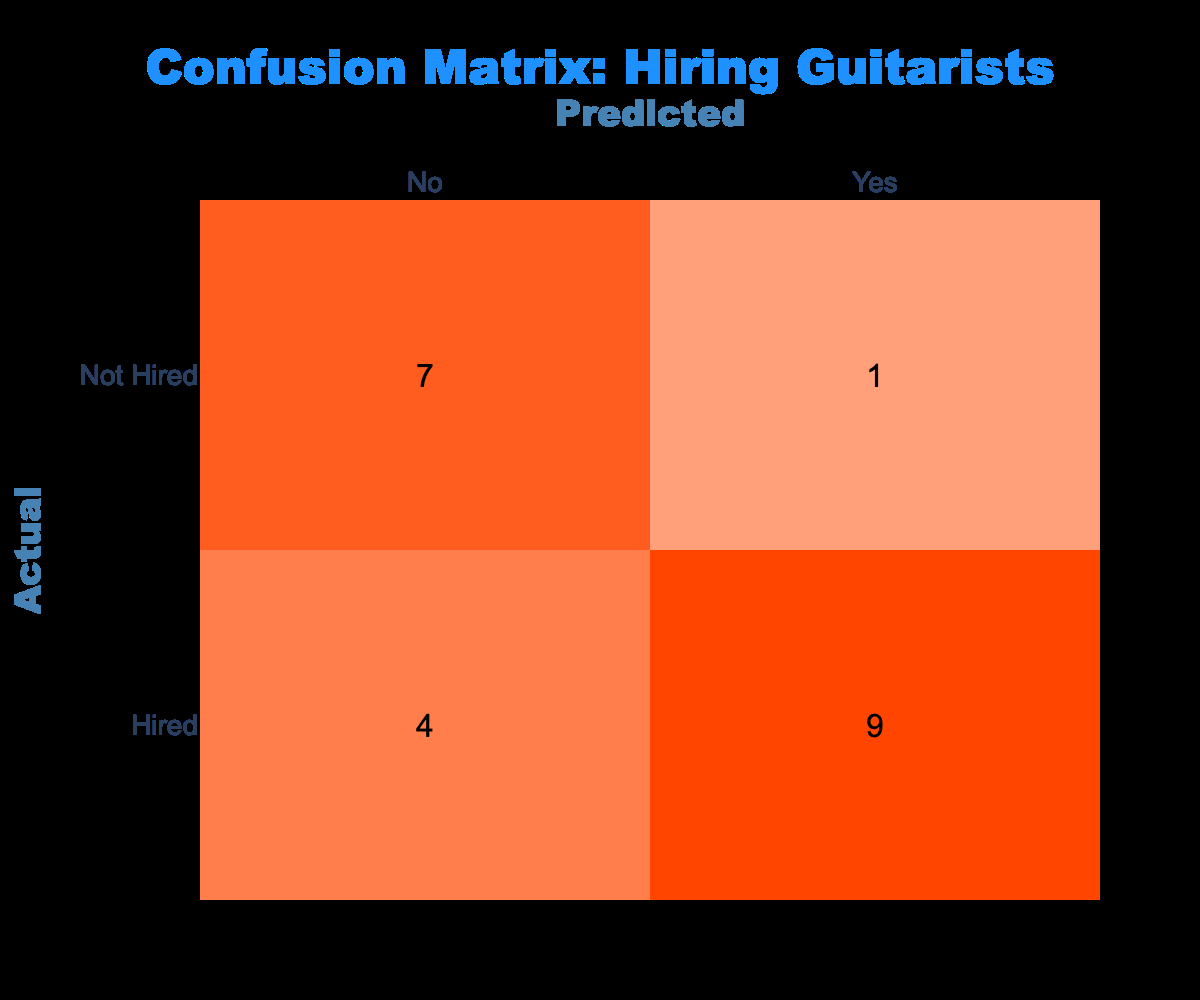What is the total number of guitarists hired? To find the total number of hired guitarists, count the occurrences of "Hired" in the "Actual" column, which gives a total of 10.
Answer: 10 How many guitarists were predicted as "Yes" but were actually not hired? Look at the "Not Hired" row under the "Yes" column, which shows there are 3 instances.
Answer: 3 What is the total number of guitarists who were not hired? Count all the occurrences of "Not Hired" in the "Actual" column, which adds up to 7.
Answer: 7 What is the difference between the number of hired guitarists and those predicted as "Yes"? The total hired is 10, and those predicted as "Yes" also total to 7 (adding both Hired Yes and Not Hired Yes), giving a difference of 10 - 7 = 3.
Answer: 3 Is it true that the number of guitarists hired is greater than the number who were predicted as "No"? Count the predicted "No", which totals 4 (combining the actual Hired No and Not Hired No). Since 10 (hired) > 4 (predicted No), the answer is true.
Answer: Yes What percentage of actual hires were predicted as "Yes"? Of the 10 hired, 7 were predicted as "Yes". To calculate percentage, (7 / 10) * 100 = 70%.
Answer: 70% How many guitarists were hired but incorrectly predicted as "No"? The count of those hired but predicted as "No" is found in the "Hired" row corresponding to "No", which is 3.
Answer: 3 What is the actual ratio of hired to not hired guitarists? There are 10 hired and 7 not hired, giving a ratio of 10:7 when simplified.
Answer: 10:7 What is the sum of hired guitarists predicted as “No” and not hired predicted as “No”? The number of hired predicted as No is 3 and not hired predicted as No is 4. Thus, summing gives 3 + 4 = 7.
Answer: 7 